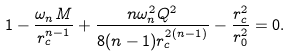<formula> <loc_0><loc_0><loc_500><loc_500>1 - \frac { \omega _ { n } M } { r _ { c } ^ { n - 1 } } + \frac { n \omega _ { n } ^ { 2 } Q ^ { 2 } } { 8 ( n - 1 ) r _ { c } ^ { 2 ( n - 1 ) } } - \frac { r _ { c } ^ { 2 } } { r _ { 0 } ^ { 2 } } = 0 .</formula> 